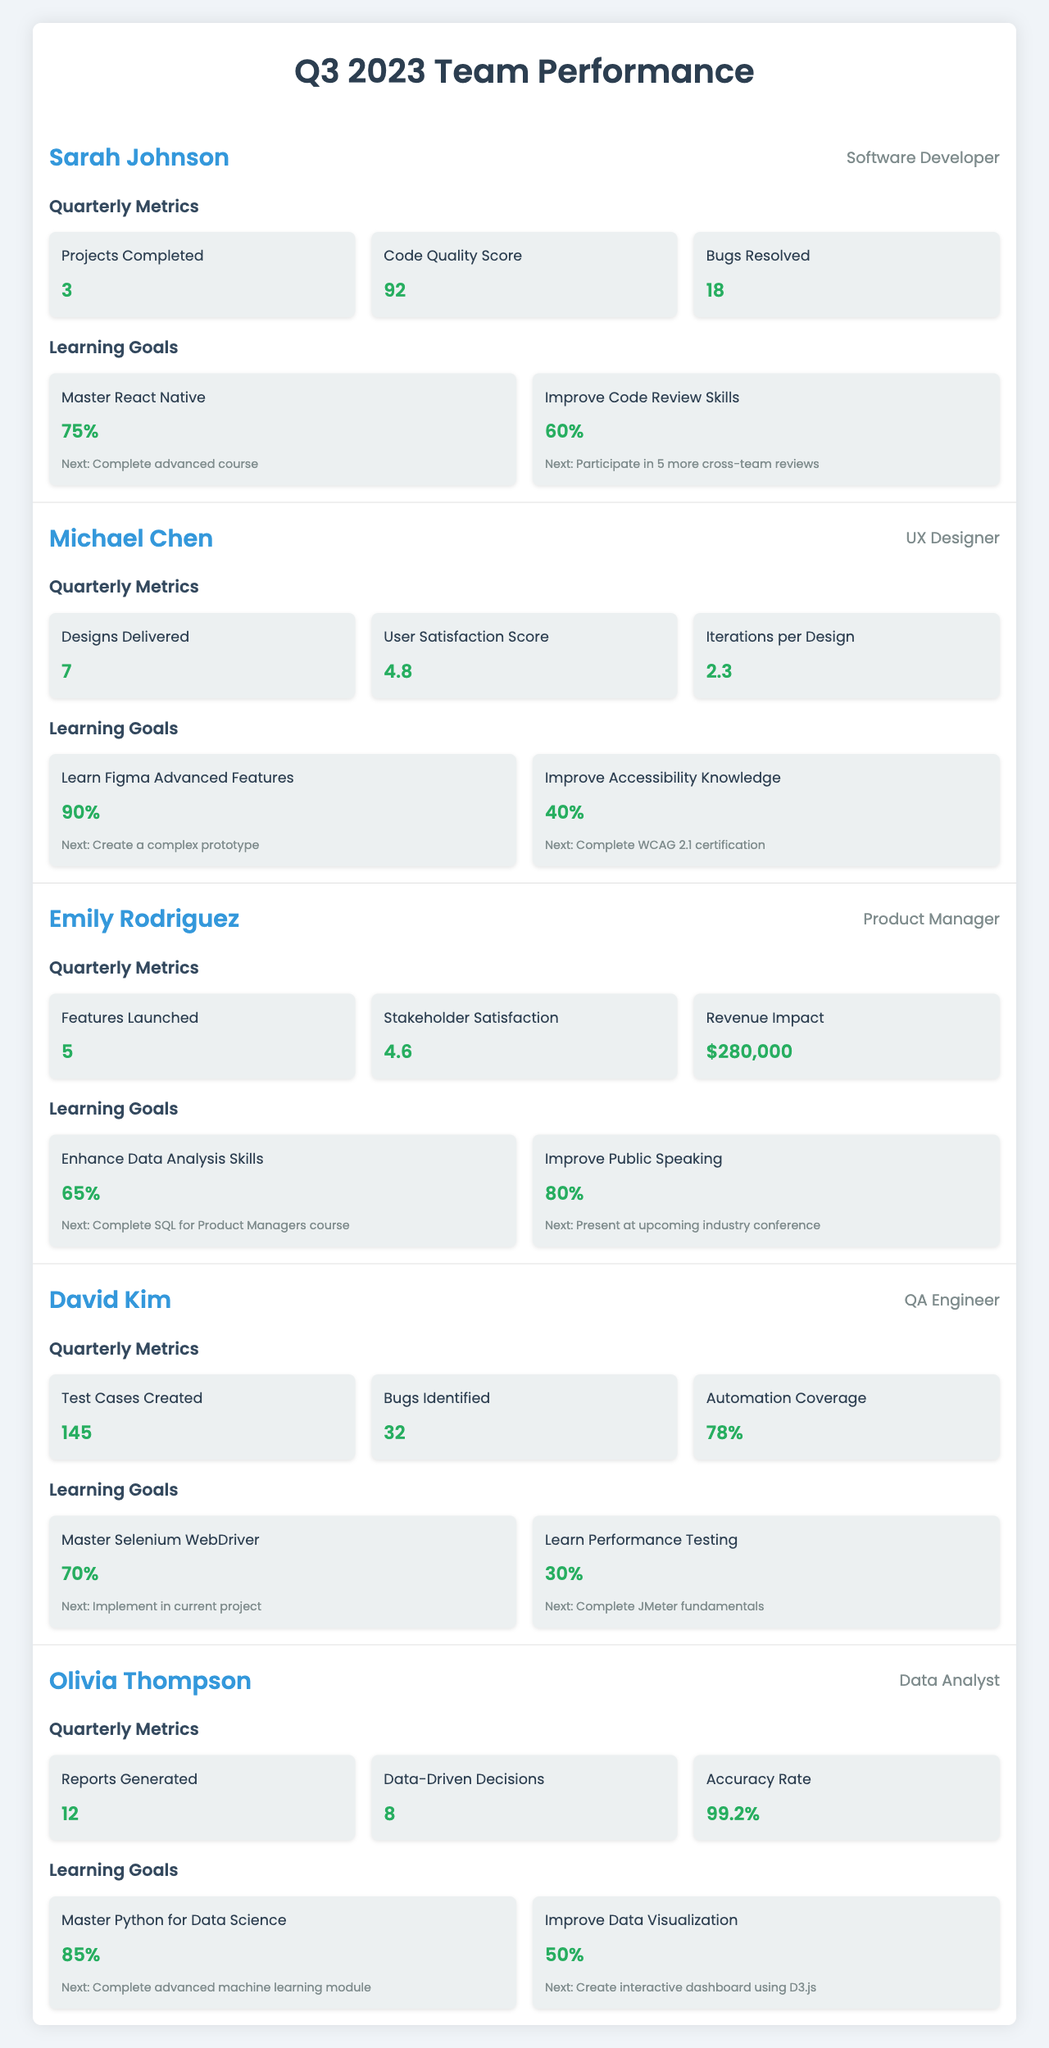What is the Code Quality Score for Sarah Johnson? The table indicates that Sarah Johnson has a Code Quality Score of 92.
Answer: 92 How many goals has Emily Rodriguez achieved 80% or more? Emily Rodriguez has achieved two goals, with one goal at 80% progress.
Answer: 1 Which team member has the highest score in User Satisfaction? Michael Chen has the highest User Satisfaction Score of 4.8 among the team members.
Answer: 4.8 What is the total number of Projects Completed by Sarah Johnson and Test Cases Created by David Kim? Sarah Johnson completed 3 projects, and David Kim created 145 test cases. The total is 3 + 145 = 148.
Answer: 148 Did Olivia Thompson achieve more than 80% progress in any of her learning goals? Yes, Olivia Thompson achieved 85% progress in her goal to Master Python for Data Science, which is more than 80%.
Answer: Yes What is the ratio of Bugs Resolved by Sarah Johnson to Bugs Identified by David Kim? Sarah Johnson resolved 18 bugs, while David Kim identified 32 bugs. The ratio is 18:32, which can be simplified to 9:16.
Answer: 9:16 How many more designs did Michael Chen deliver compared to the average number of reports generated by Olivia Thompson? Michael Chen delivered 7 designs, while Olivia Thompson generated 12 reports. The average of 12 is also 12, and 7 is less. Therefore, Michael delivered 5 less.
Answer: 5 less What percentage of Automation Coverage does David Kim have? David Kim has an Automation Coverage of 78%, as stated in the table.
Answer: 78% Is it true that Emily Rodriguez launched more features than David Kim created test cases? Yes, Emily Rodriguez launched 5 features, while David Kim created 145 test cases, which is much higher.
Answer: No How does the combined progress of Sarah Johnson's learning goals compare to David Kim's? Sarah Johnson's goals are 75% and 60%, averaging 67.5%, while David Kim's goals average 50%. Sarah's progress is greater.
Answer: Higher 